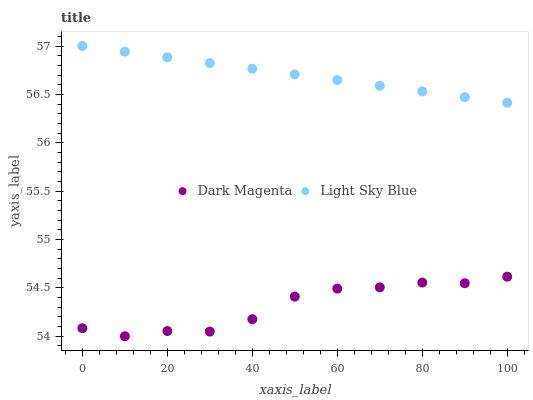Does Dark Magenta have the minimum area under the curve?
Answer yes or no. Yes. Does Light Sky Blue have the maximum area under the curve?
Answer yes or no. Yes. Does Dark Magenta have the maximum area under the curve?
Answer yes or no. No. Is Light Sky Blue the smoothest?
Answer yes or no. Yes. Is Dark Magenta the roughest?
Answer yes or no. Yes. Is Dark Magenta the smoothest?
Answer yes or no. No. Does Dark Magenta have the lowest value?
Answer yes or no. Yes. Does Light Sky Blue have the highest value?
Answer yes or no. Yes. Does Dark Magenta have the highest value?
Answer yes or no. No. Is Dark Magenta less than Light Sky Blue?
Answer yes or no. Yes. Is Light Sky Blue greater than Dark Magenta?
Answer yes or no. Yes. Does Dark Magenta intersect Light Sky Blue?
Answer yes or no. No. 